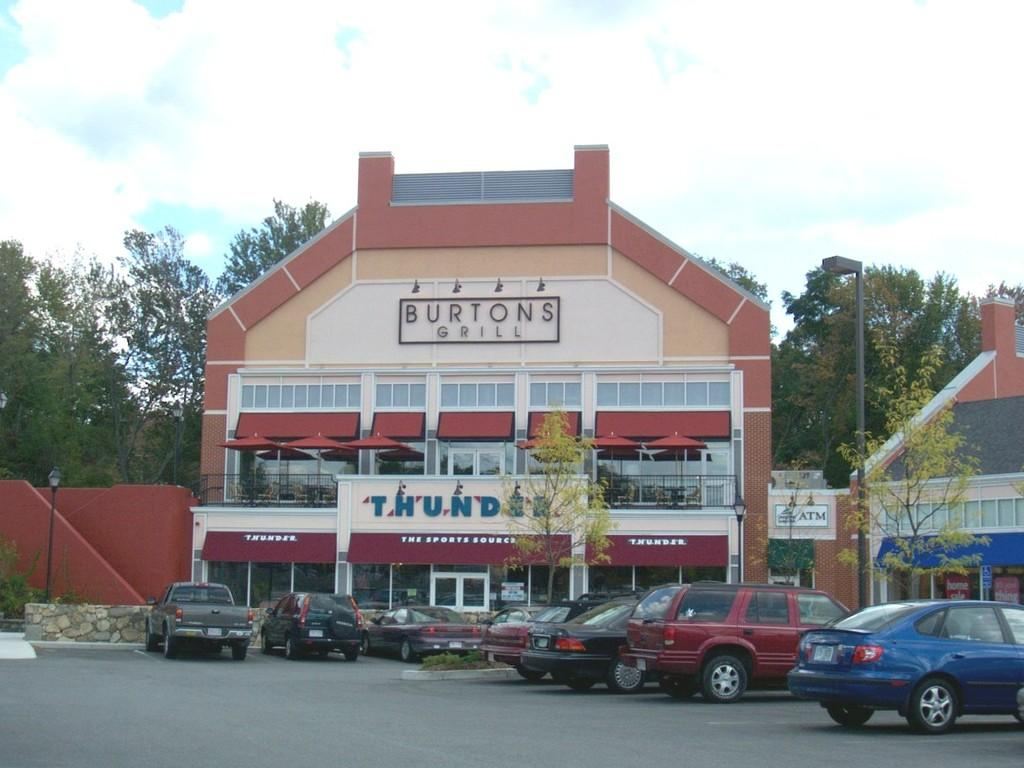What is the main subject in the center of the image? There is a building and a tree in the center of the image. What can be seen on the road at the bottom of the image? Vehicles are visible on the road at the bottom of the image. What is visible in the background of the image? There are trees and the sky in the background of the image. What can be observed in the sky in the background of the image? Clouds are present in the background of the image. What type of pancake is being served at the restaurant in the image? There is no restaurant or pancake present in the image. How many mittens are visible on the tree in the image? There are no mittens visible on the tree in the image. 